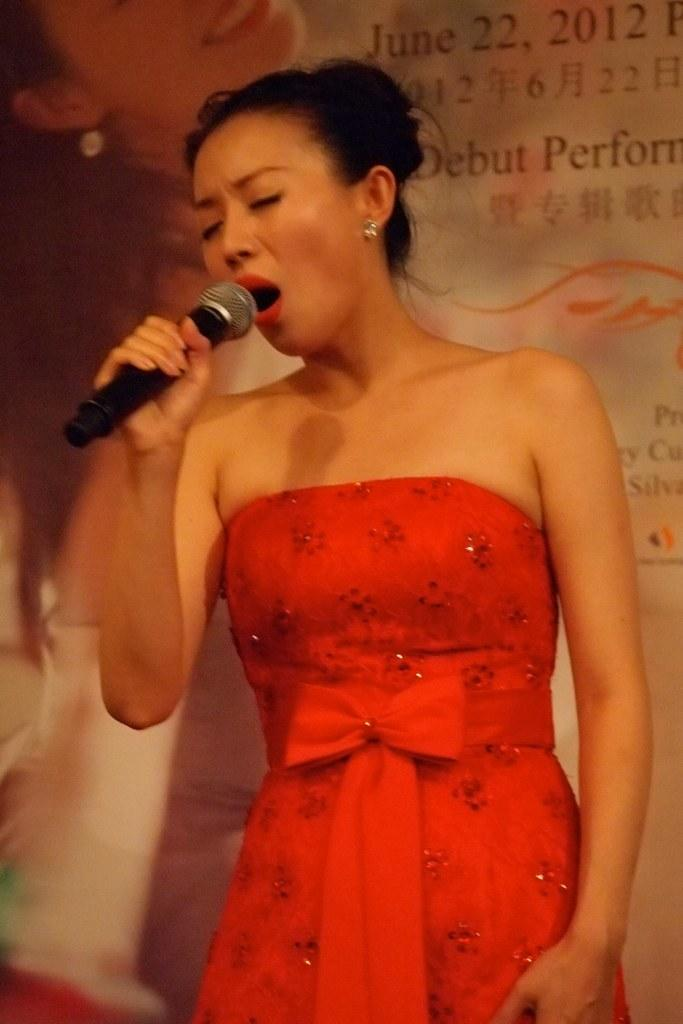Who is the main subject in the image? There is a woman in the image. Where is the woman positioned in the image? The woman is standing in the middle of the image. What is the woman holding in the image? The woman is holding a microphone. What is the woman doing in the image? The woman is singing. What can be seen behind the woman in the image? There is a banner behind the woman. What type of leather is used to make the woman's shoes in the image? There is no information about the woman's shoes in the image, so we cannot determine the type of leather used. 